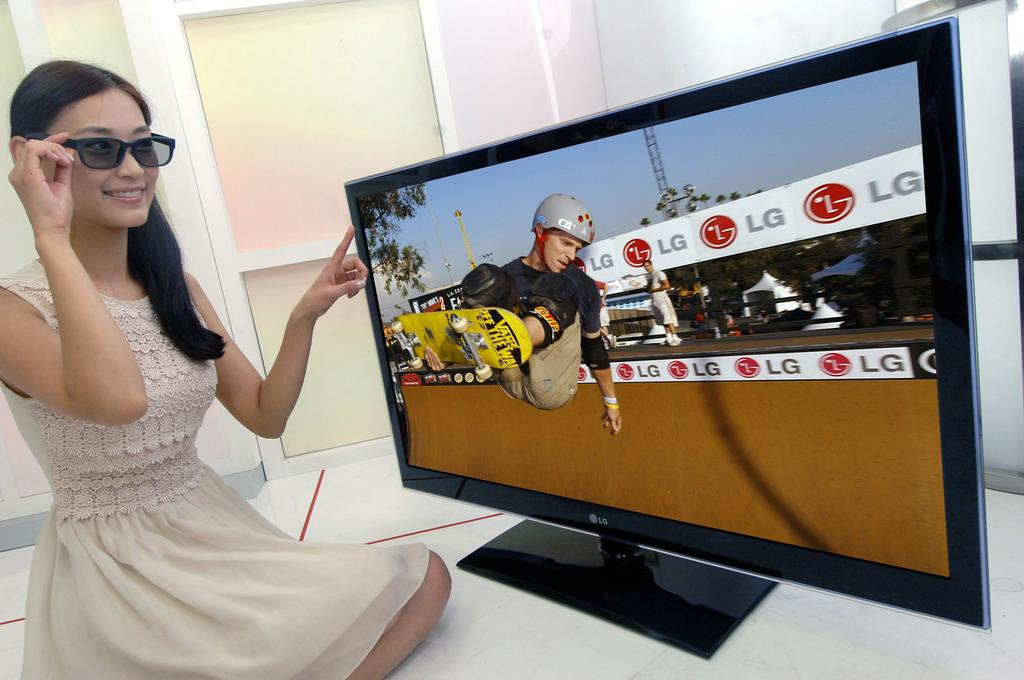<image>
Share a concise interpretation of the image provided. A woman wearing glasses sits in front of an LG television watching a skateboarder. 